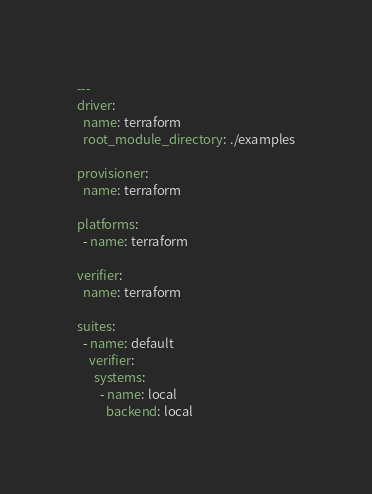<code> <loc_0><loc_0><loc_500><loc_500><_YAML_>---
driver:
  name: terraform
  root_module_directory: ./examples

provisioner:
  name: terraform

platforms:
  - name: terraform

verifier:
  name: terraform

suites:
  - name: default
    verifier:
      systems:
        - name: local
          backend: local
</code> 